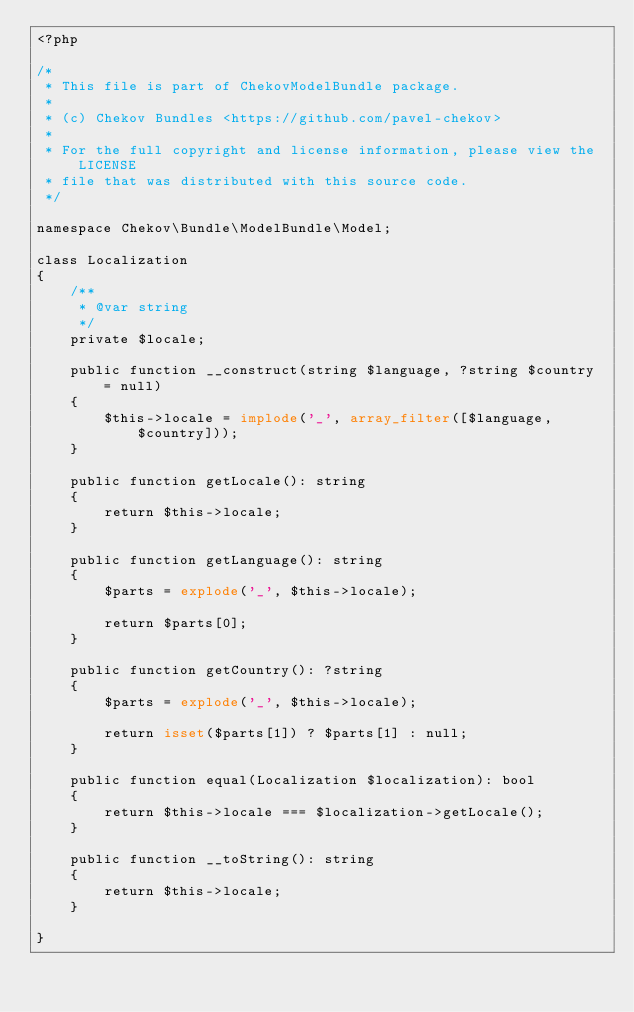<code> <loc_0><loc_0><loc_500><loc_500><_PHP_><?php

/*
 * This file is part of ChekovModelBundle package.
 *
 * (c) Chekov Bundles <https://github.com/pavel-chekov>
 *
 * For the full copyright and license information, please view the LICENSE
 * file that was distributed with this source code.
 */

namespace Chekov\Bundle\ModelBundle\Model;

class Localization
{
    /**
     * @var string
     */
    private $locale;

    public function __construct(string $language, ?string $country = null)
    {
        $this->locale = implode('_', array_filter([$language, $country]));
    }

    public function getLocale(): string
    {
        return $this->locale;
    }

    public function getLanguage(): string
    {
        $parts = explode('_', $this->locale);

        return $parts[0];
    }

    public function getCountry(): ?string
    {
        $parts = explode('_', $this->locale);

        return isset($parts[1]) ? $parts[1] : null;
    }

    public function equal(Localization $localization): bool
    {
        return $this->locale === $localization->getLocale();
    }

    public function __toString(): string
    {
        return $this->locale;
    }

}
</code> 